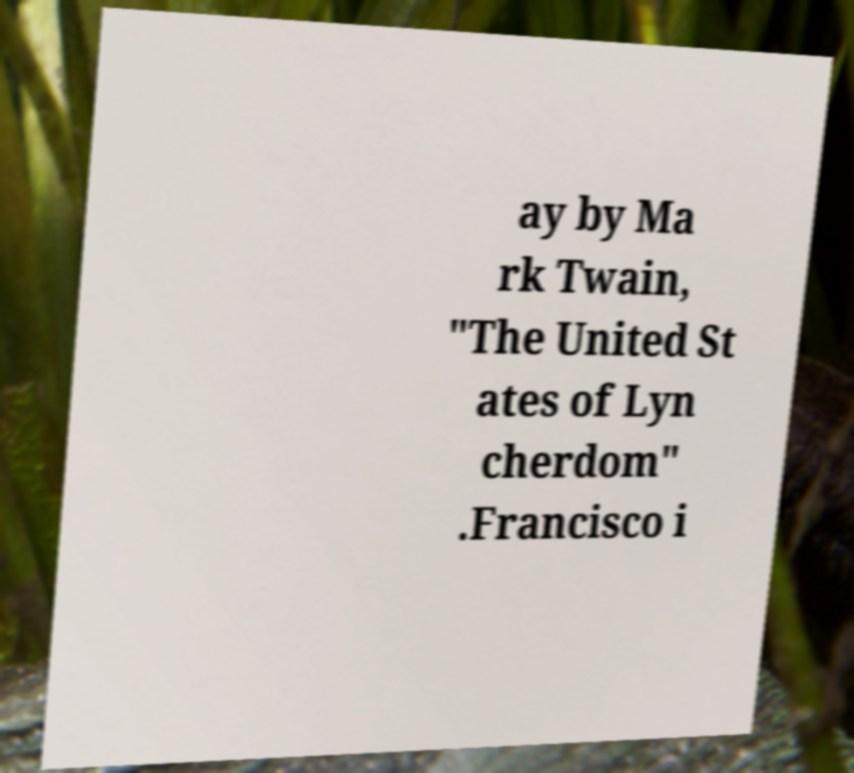Can you accurately transcribe the text from the provided image for me? ay by Ma rk Twain, "The United St ates of Lyn cherdom" .Francisco i 